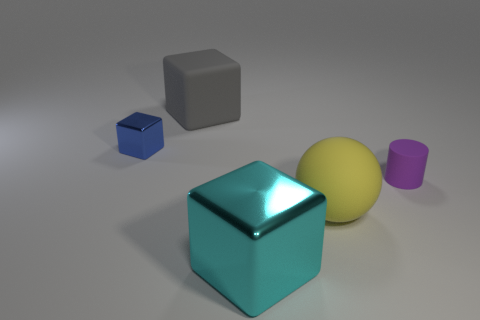Subtract all large cyan blocks. How many blocks are left? 2 Add 2 purple things. How many objects exist? 7 Subtract all cubes. How many objects are left? 2 Add 3 small purple cylinders. How many small purple cylinders are left? 4 Add 1 tiny rubber things. How many tiny rubber things exist? 2 Subtract 0 purple blocks. How many objects are left? 5 Subtract all metal blocks. Subtract all blocks. How many objects are left? 0 